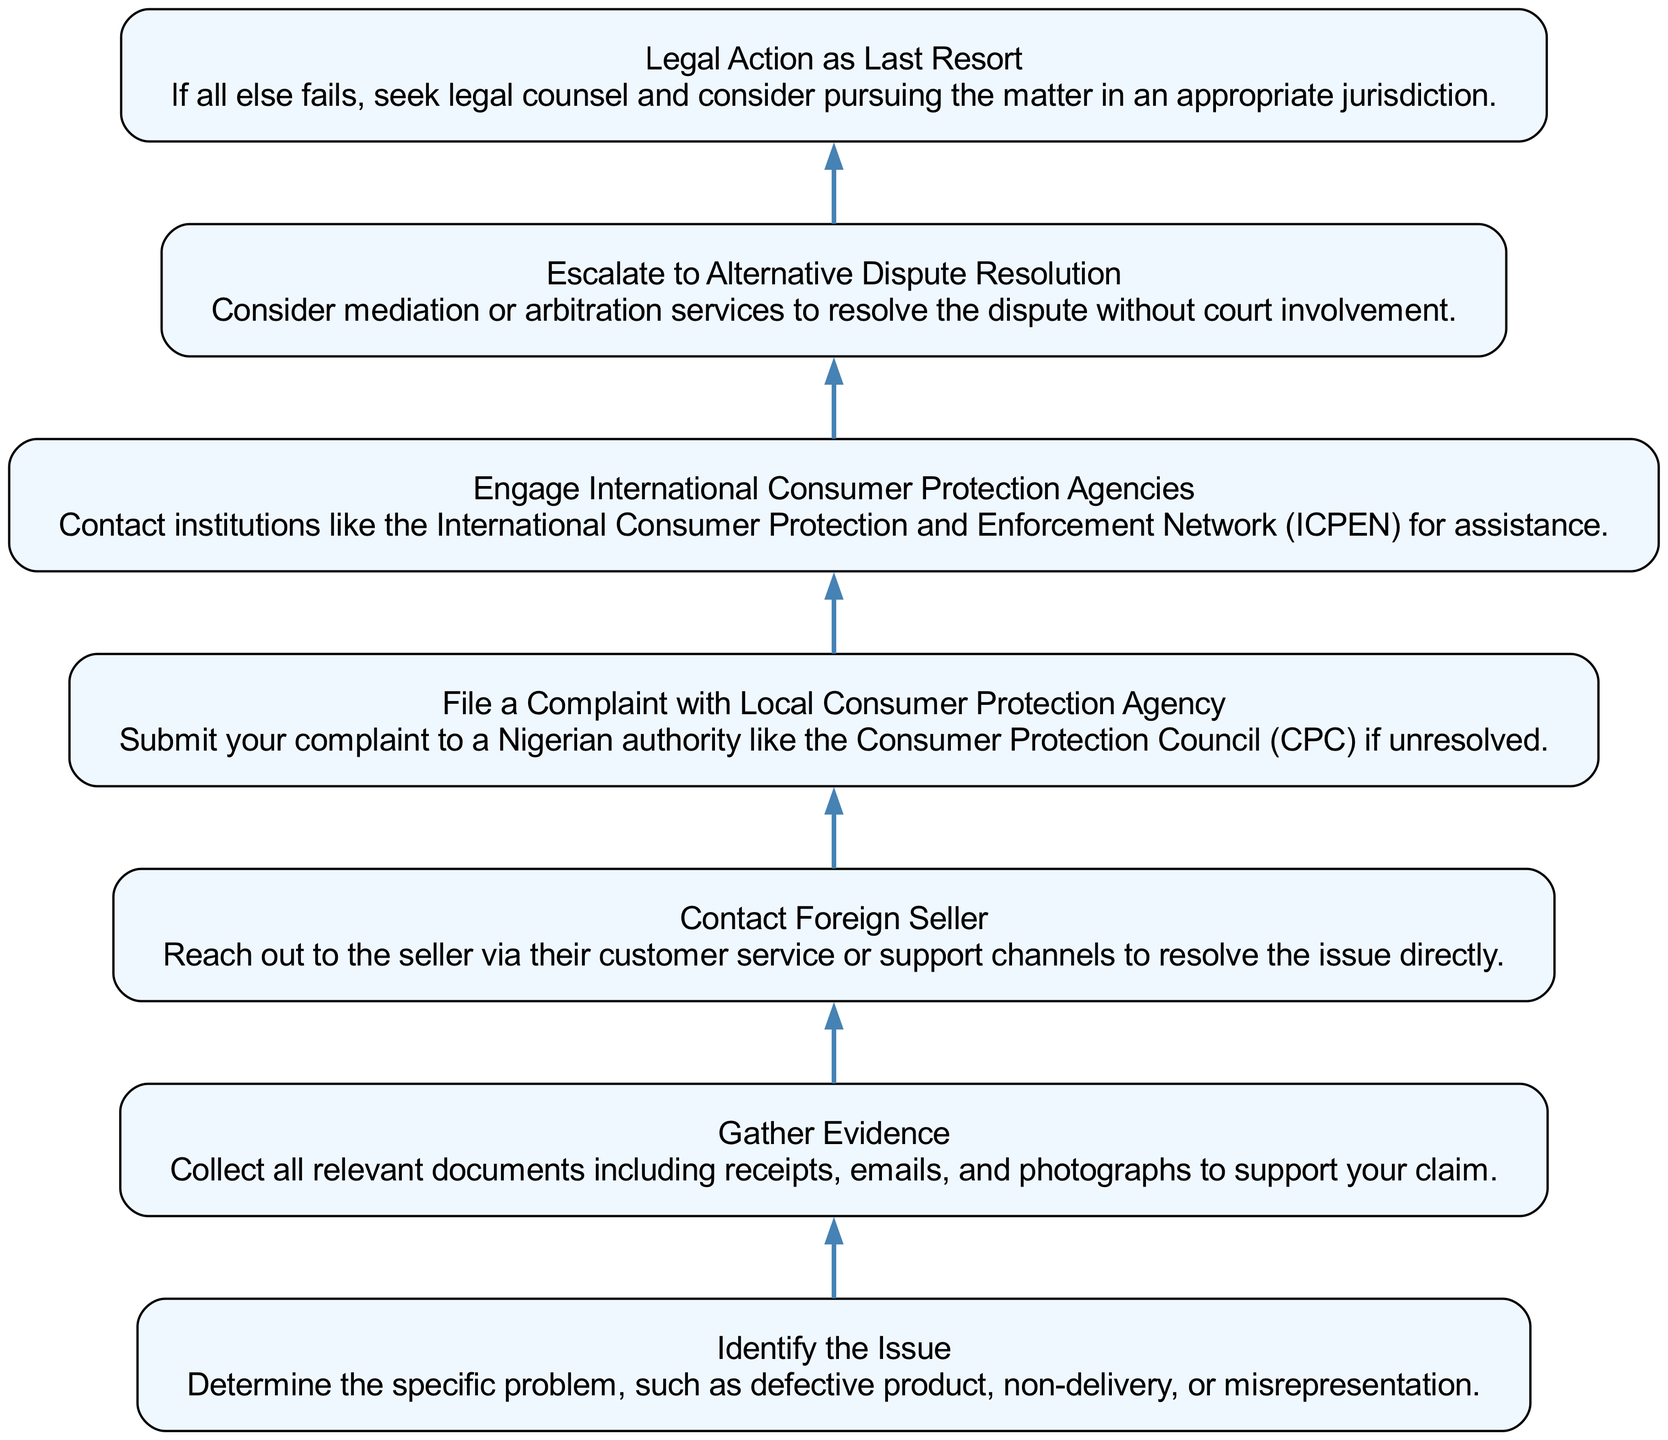What is the first step in the complaint process? The diagram indicates the first step is "Identify the Issue." This is the topmost node showing the starting point of the process.
Answer: Identify the Issue How many steps are involved in filing a complaint against a foreign seller? By counting the nodes in the diagram, there are a total of 7 steps represented. Each step corresponds to a node in the flow chart.
Answer: 7 Which step comes after "Gather Evidence"? The diagram shows a direct connection from "Gather Evidence" to "Contact Foreign Seller." This can be interpreted by identifying the nodes and the sequential relationship drawn in the diagram.
Answer: Contact Foreign Seller What is the last option mentioned in the complaint process? The final step in the diagram is "Legal Action as Last Resort," representing the end of the process. This can be confirmed by locating the bottom node in the flow chart.
Answer: Legal Action as Last Resort Which step involves reaching out to the seller? The node titled "Contact Foreign Seller" specifically represents the action of reaching out to the seller for resolution. This is explicitly listed as one of the steps.
Answer: Contact Foreign Seller What action should be taken if the issue is unresolved after contacting the seller? According to the flow chart, the next appropriate action, if unresolved, is to "File a Complaint with Local Consumer Protection Agency." This follows logically after trying to solve the issue directly.
Answer: File a Complaint with Local Consumer Protection Agency What is the relationship between "Escalate to Alternative Dispute Resolution" and "Engage International Consumer Protection Agencies"? "Engage International Consumer Protection Agencies" proceeds to follow "File a Complaint with Local Consumer Protection Agency" and then leads to "Escalate to Alternative Dispute Resolution." This indicates sequential progression in the complaint process.
Answer: Sequential progression 